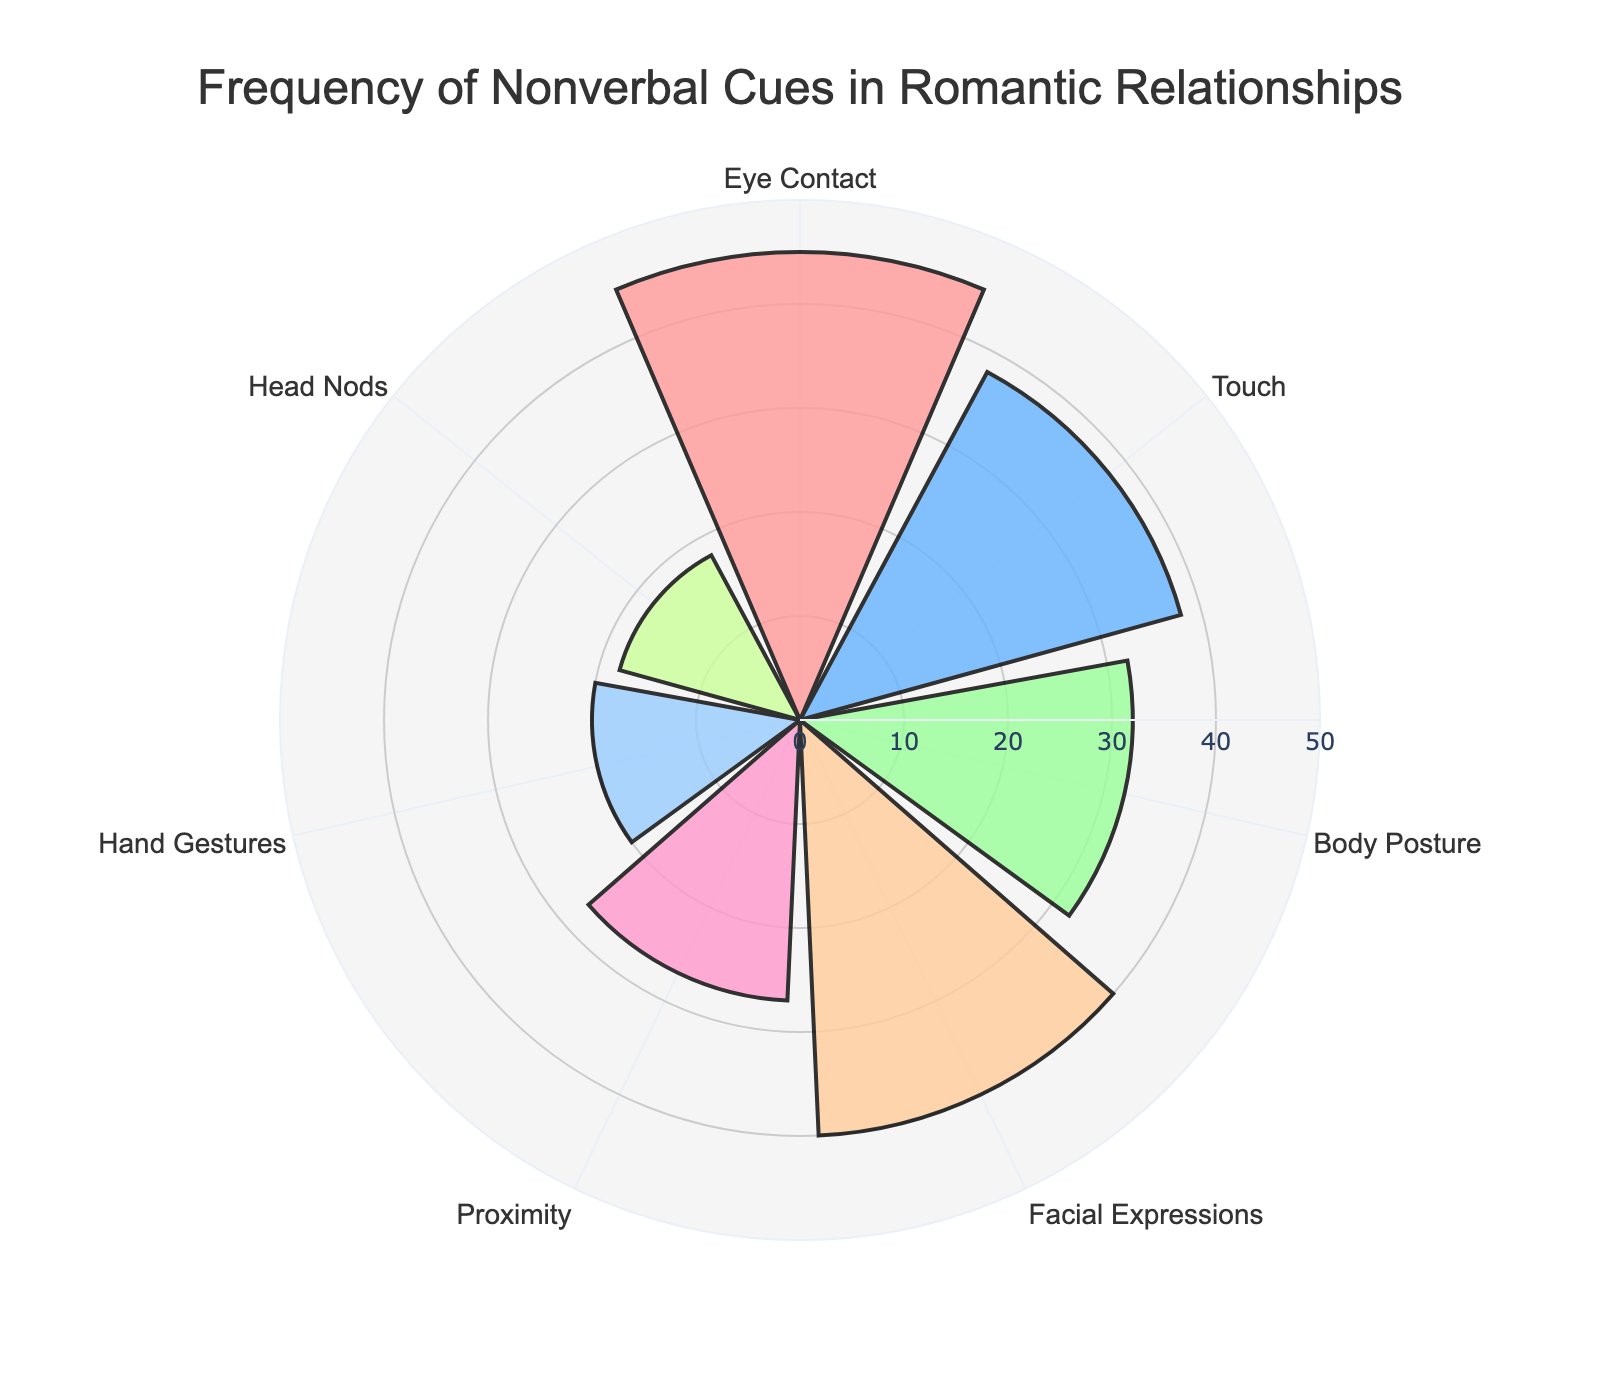What is the title of the figure? The title is usually located at the top of the figure. In this case, by looking at the top center, you'll see the title that describes the focus of the data.
Answer: Frequency of Nonverbal Cues in Romantic Relationships How many types of nonverbal cues are displayed? By counting the number of different types (or categories) on the chart, we can determine the total number.
Answer: 7 Which nonverbal cue has the highest frequency? Locate the bar segment with the highest radial distance from the center of the rose chart and read the associated type.
Answer: Eye Contact Which nonverbal cue has the lowest frequency? Find the bar segment with the shortest radial distance from the center of the rose chart and identify its associated type.
Answer: Head Nods What's the difference in frequency between Eye Contact and Touch? First, find the frequencies of Eye Contact (45) and Touch (38). Next, subtract the smaller frequency from the larger one: 45 - 38.
Answer: 7 What is the sum of the frequencies of Body Posture and Facial Expressions? Find the frequencies of Body Posture (32) and Facial Expressions (40). Then, add the two frequencies together: 32 + 40.
Answer: 72 Which nonverbal cue is more frequent: Proximity or Hand Gestures? Compare the radial distances of Proximity (27) and Hand Gestures (20). Since 27 is greater than 20, Proximity is more frequent.
Answer: Proximity What is the average frequency of all the nonverbal cues? Sum all the frequencies: 45 + 38 + 32 + 40 + 27 + 20 + 18 = 220. Then, divide by the number of types (7): 220 / 7.
Answer: 31.43 How does the frequency of Head Nods compare to the average frequency of all nonverbal cues? The frequency of Head Nods is 18. From the previous question, the average frequency is 31.43. Since 18 is less than 31.43, Head Nods are below average in frequency.
Answer: Below average 